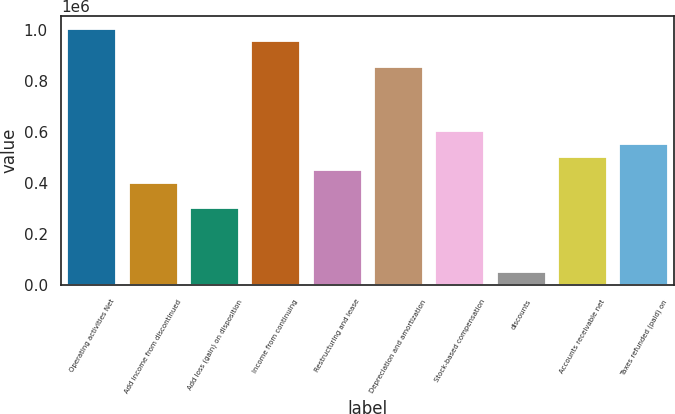<chart> <loc_0><loc_0><loc_500><loc_500><bar_chart><fcel>Operating activities Net<fcel>Add income from discontinued<fcel>Add loss (gain) on disposition<fcel>Income from continuing<fcel>Restructuring and lease<fcel>Depreciation and amortization<fcel>Stock-based compensation<fcel>discounts<fcel>Accounts receivable net<fcel>Taxes refunded (paid) on<nl><fcel>1.00436e+06<fcel>401844<fcel>301424<fcel>954154<fcel>452054<fcel>853734<fcel>602684<fcel>50374<fcel>502264<fcel>552474<nl></chart> 